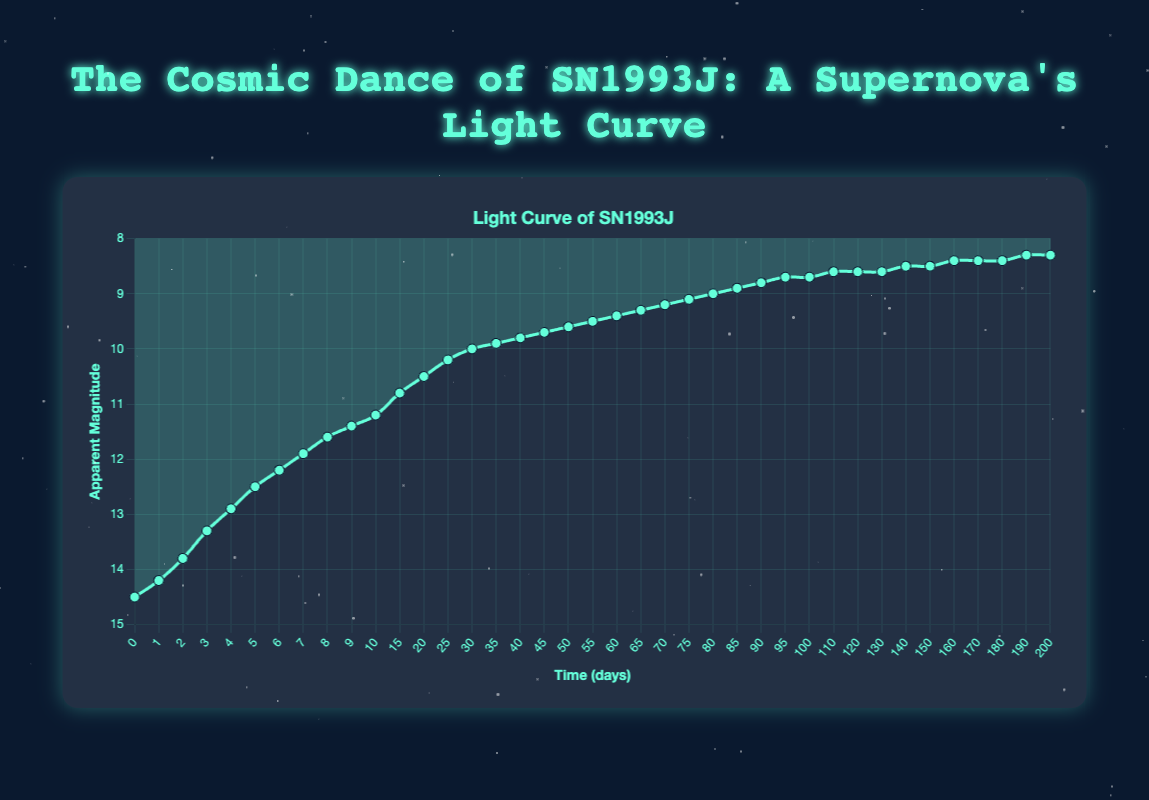What's the apparent magnitude of the supernova at day 10? The plot shows a descending curve that indicates the apparent magnitude over time. Referring to the data point at day 10 on the x-axis and looking up to the y-axis, we find that the apparent magnitude is marked.
Answer: 11.2 How much did the apparent magnitude decrease from day 0 to day 10? From the figure, the apparent magnitude at day 0 is 14.5 and at day 10 is 11.2. The decrease in apparent magnitude is the difference between these two values: 14.5 - 11.2 = 3.3
Answer: 3.3 Between which days does the apparent magnitude change most rapidly? One can visually assess the rate of change by the steepness of the curve in different segments. From the figure, the most rapid change seems to occur between days 0 and 10, where the curve is steepest.
Answer: 0 to 10 Does the apparent magnitude stabilize after a certain point? By examining the latter part of the curve, we notice it becomes almost horizontal, indicating stabilization. Specifically, after around day 100, the values stop changing significantly.
Answer: After day 100 What is the average apparent magnitude from day 0 to day 20? To find the average, sum the apparent magnitudes at days 0, 10, and 20, and then divide by 3: (14.5 + 11.2 + 10.5) = 36.2. The average is 36.2 / 3 = 12.07
Answer: 12.07 How does the apparent magnitude on day 50 compare to that on day 200? Referring to the figure, the apparent magnitude at day 50 is 9.6 and at day 200 is 8.3. Since lower values indicate brighter magnitudes, the supernova is brighter on day 200.
Answer: Day 200 is brighter Is there any period where the apparent magnitude remains the same for consecutive intervals? Checking the plot closely, we can see that from day 100 to 120, the apparent magnitude is constant at 8.6. This suggests the brightness did not change in this period.
Answer: Day 100 to 120 What is the rate of change in apparent magnitude between day 15 and day 30? To calculate this, we subtract the apparent magnitude at day 30 from that at day 15 and then divide by the time interval. (10.8 - 10.0) / (30 - 15) = 0.8 / 15 ≈ 0.053 magnitude per day.
Answer: ≈ 0.053 magnitude per day During which days does the curve appear least steep, indicating the slowest rate of change in apparent magnitude? From the visual inspection of the sloping curve, the segment from day 100 to day 200 has the least steep slope, indicating the slowest rate of change.
Answer: Day 100 to 200 